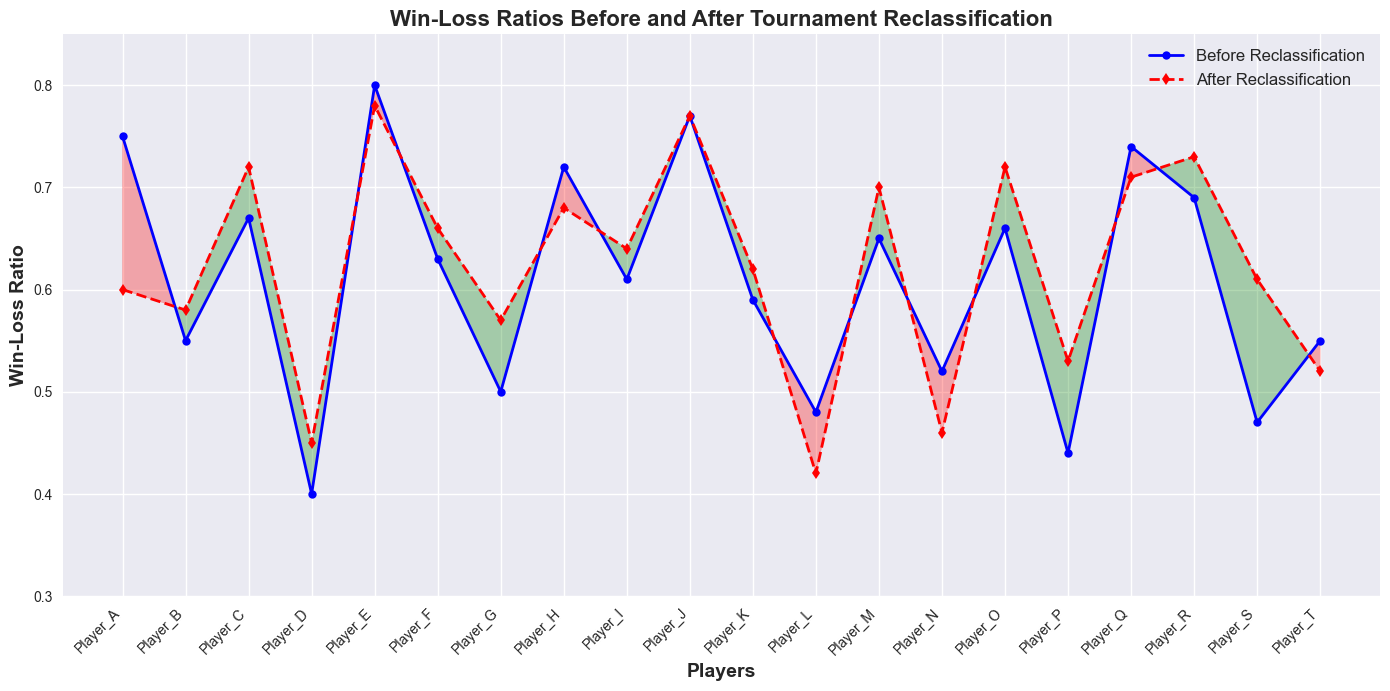What's the win-loss ratio for Player_A before and after reclassification? The win-loss ratios for Player_A can be directly read from the plot. Locate the points labeled 'Player_A' and read the values from the 'Before Reclassification' (blue line) and 'After Reclassification' (red line).
Answer: 0.75 and 0.60 Which player had the highest win-loss ratio before reclassification? To find the player with the highest win-loss ratio before reclassification, look for the peak point on the blue line. The player corresponding to this peak point is Player_E.
Answer: Player_E Did Player_S's win-loss ratio improve or worsen after reclassification? To determine this, compare the position of the two points for Player_S on the blue and red lines. The red point is higher for Player_S, indicating an improvement.
Answer: Improved Which player's win-loss ratio remained unchanged after reclassification? To find the player with unchanged win-loss ratios, look for overlapping points on the blue and red lines. This occurs at Player_J.
Answer: Player_J How many players had a better win-loss ratio after reclassification compared to before? Count the number of players where the red line points are above the blue line points. Players with improvements are Player_B, Player_C, Player_D, Player_F, Player_G, Player_I, Player_K, Player_M, Player_O, Player_P, Player_R, and Player_S.
Answer: 12 players What's the difference in win-loss ratio for Player_L before and after reclassification? Subtract the after reclassification value from the before reclassification value for Player_L (0.48 - 0.42).
Answer: 0.06 Which player experienced the biggest drop in win-loss ratio after reclassification? Identify the player with the most significant decline by finding the largest vertical drop from blue to red. Player_A dropped from 0.75 to 0.60, a decline of 0.15.
Answer: Player_A How many players had a ratio below 0.5 before reclassification and above 0.5 after reclassification? Look for players with values below 0.5 on the blue line and above 0.5 on the red line. The players that meet this criterion are Player_P and Player_S.
Answer: 2 players On average, did the players' win-loss ratios improve or worsen after reclassification? Calculate the average win-loss ratio before and after reclassification, then compare. The sum of the ratios before is 10.34 and after is 10.66. Because the average after reclassification (0.533) is slightly higher than before (0.517), on average, the ratios improved.
Answer: Improved Which players have a win-loss ratio below 0.6 before reclassification and also saw an improvement? Locate players with a ratio below 0.6 on the blue line who have a higher point on the red line. This includes Player_B, Player_D, Player_G, Player_P, and Player_S.
Answer: Player_B, Player_D, Player_G, Player_P, Player_S 